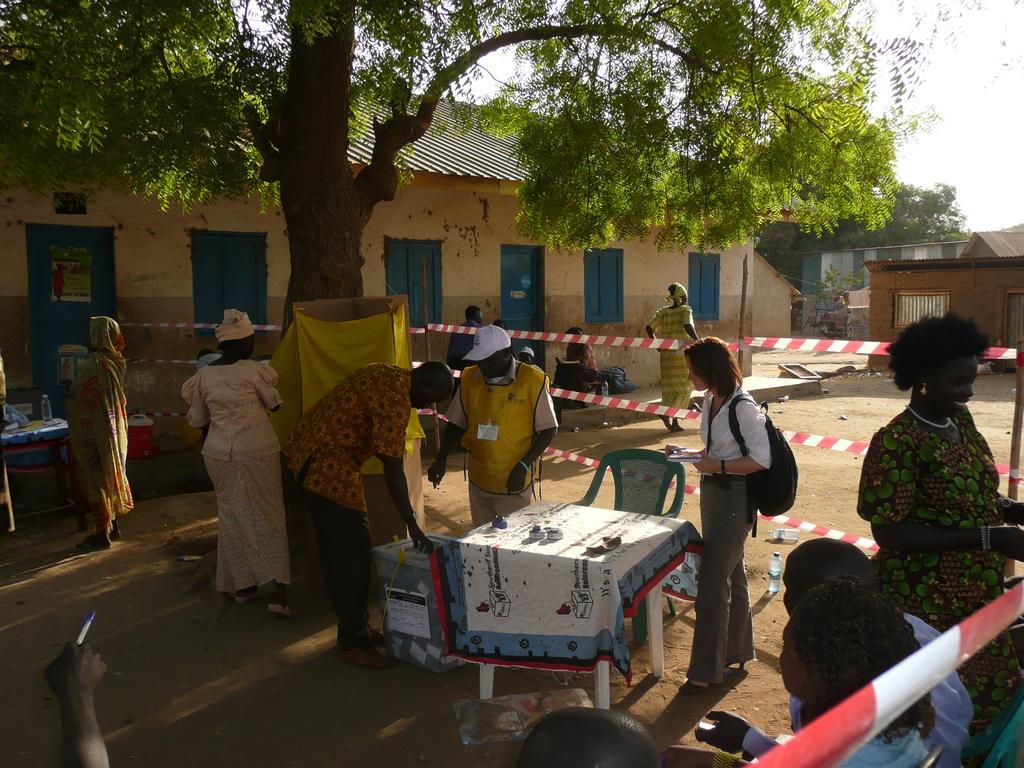Please provide a concise description of this image. In this image there is a group of person. There is a woman who is wearing a white shirt and a bag. On the table which contains a cloth and some objects. There is a blue color chair. On the top we can see a tree. On the background there is a building , in-front of the building there is a door and windows. 